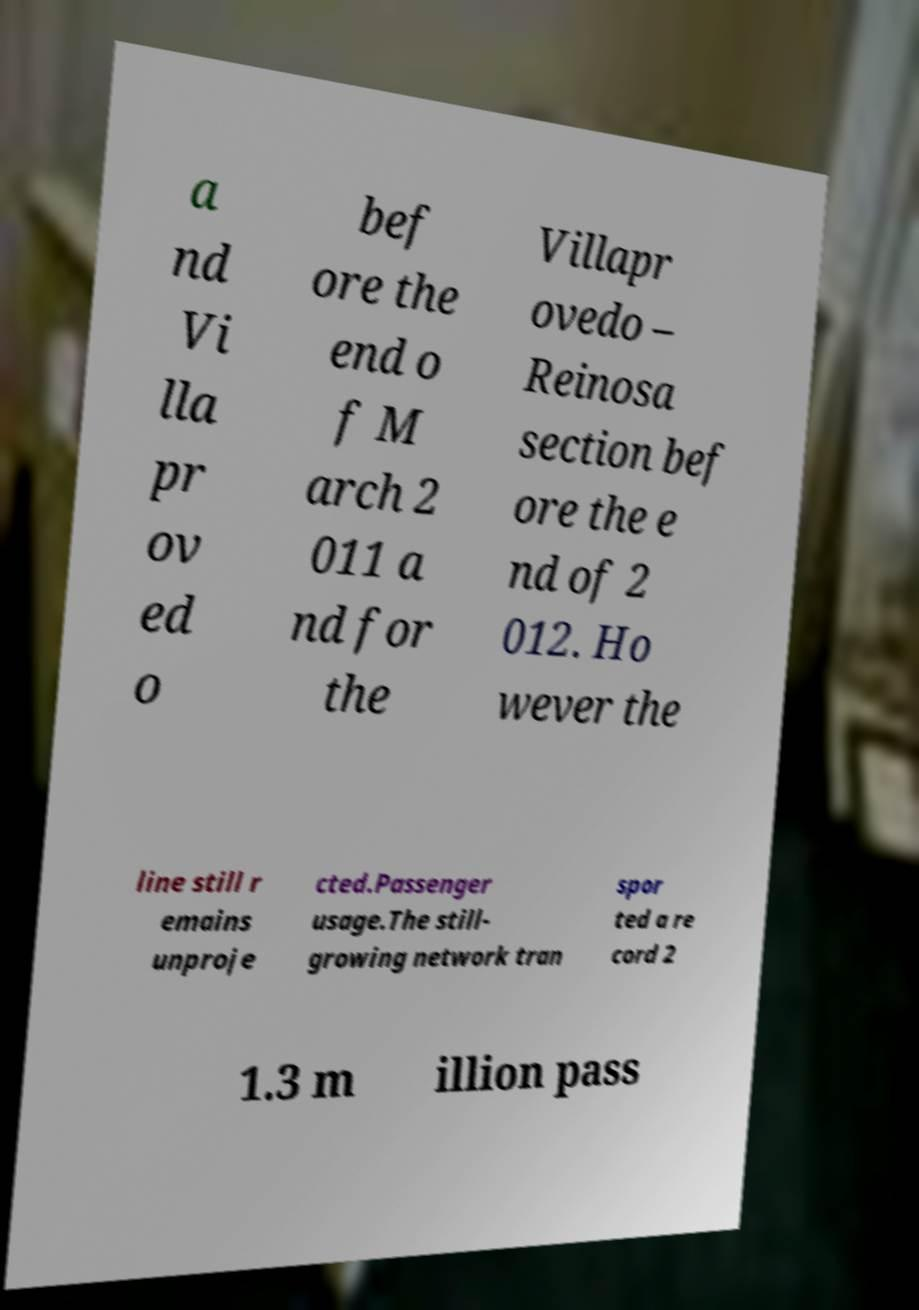Could you extract and type out the text from this image? a nd Vi lla pr ov ed o bef ore the end o f M arch 2 011 a nd for the Villapr ovedo – Reinosa section bef ore the e nd of 2 012. Ho wever the line still r emains unproje cted.Passenger usage.The still- growing network tran spor ted a re cord 2 1.3 m illion pass 